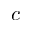Convert formula to latex. <formula><loc_0><loc_0><loc_500><loc_500>c</formula> 